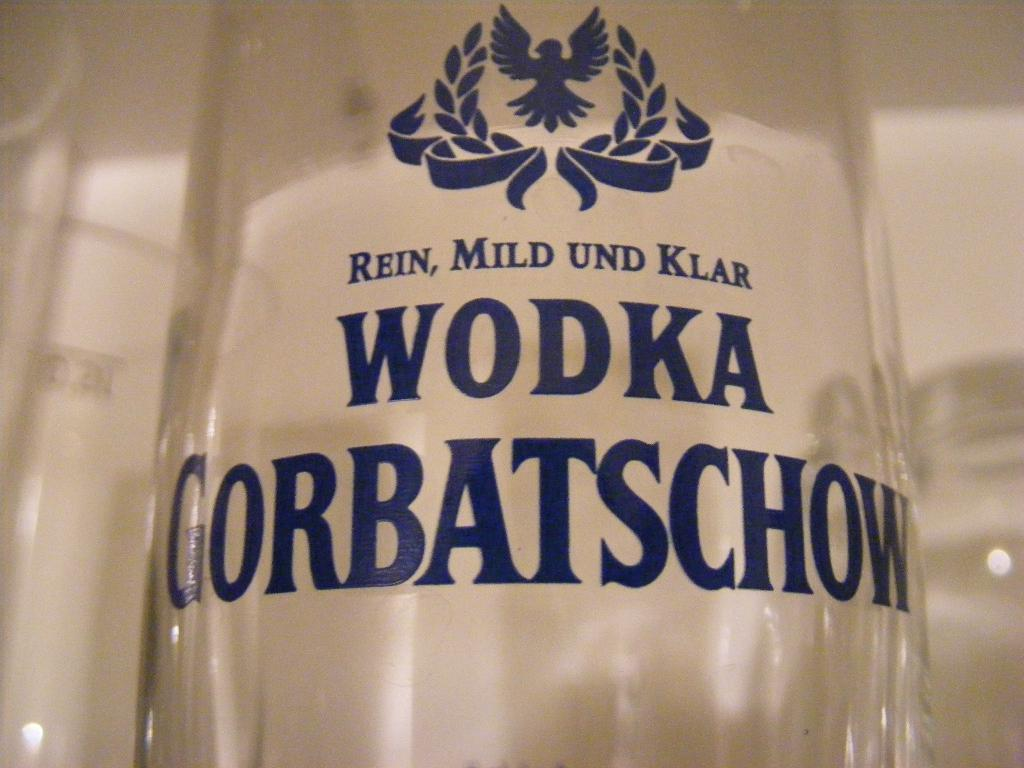What object can be seen in the image? There is a bottle in the image. How many pairs of shoes are visible in the alley next to the bottle? There is no alley or shoes present in the image; it only features a bottle. 